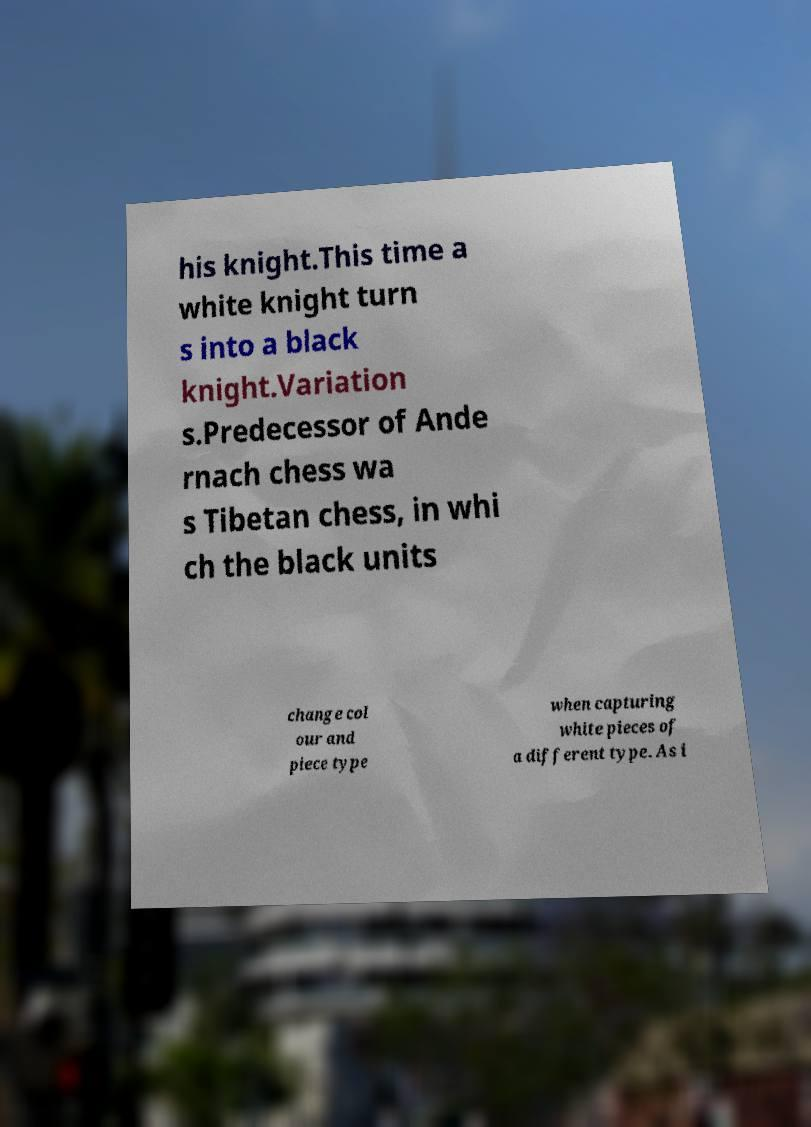Please identify and transcribe the text found in this image. his knight.This time a white knight turn s into a black knight.Variation s.Predecessor of Ande rnach chess wa s Tibetan chess, in whi ch the black units change col our and piece type when capturing white pieces of a different type. As i 